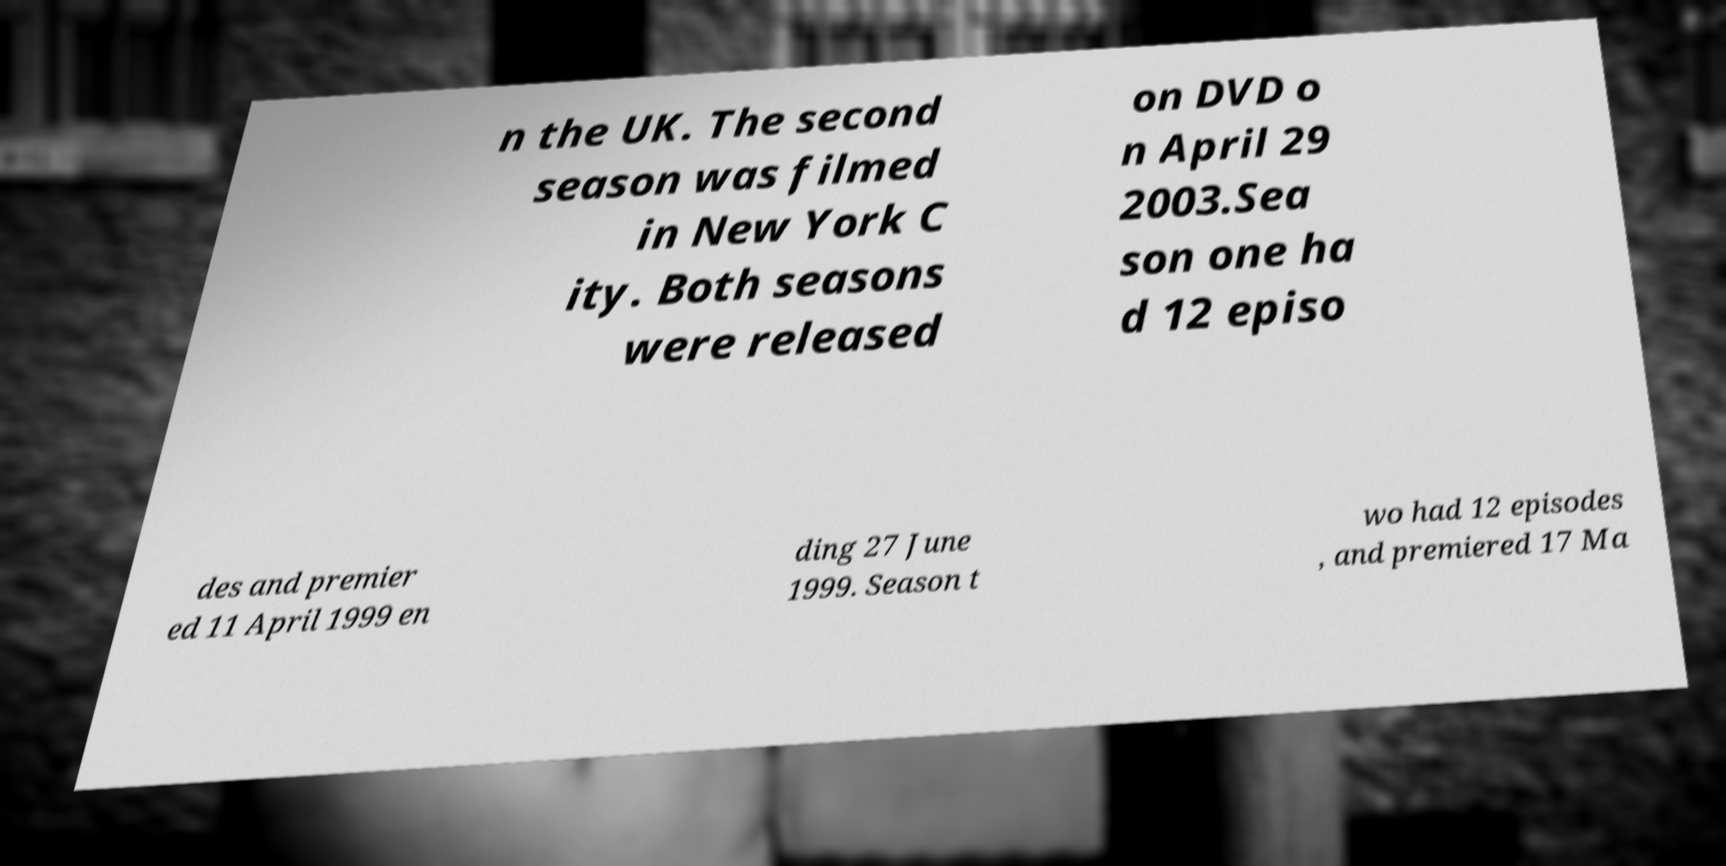Can you accurately transcribe the text from the provided image for me? n the UK. The second season was filmed in New York C ity. Both seasons were released on DVD o n April 29 2003.Sea son one ha d 12 episo des and premier ed 11 April 1999 en ding 27 June 1999. Season t wo had 12 episodes , and premiered 17 Ma 